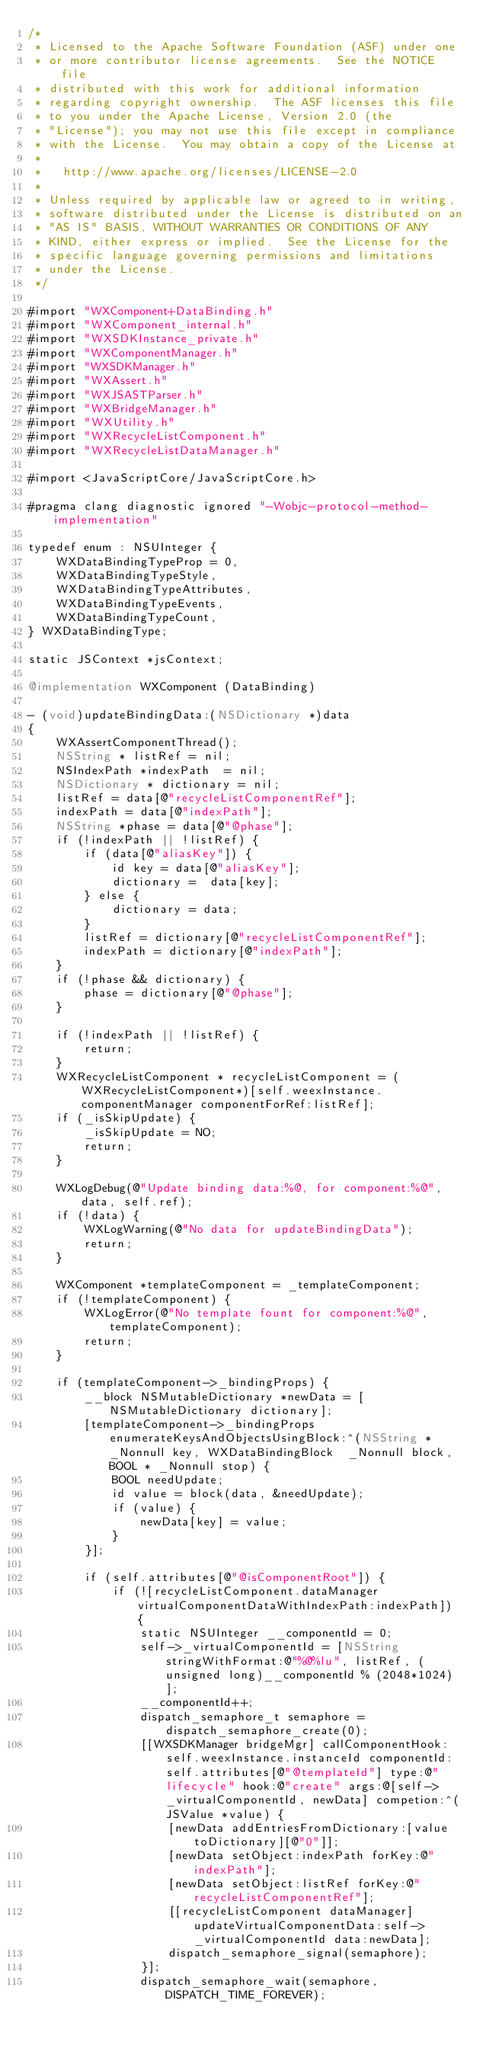<code> <loc_0><loc_0><loc_500><loc_500><_ObjectiveC_>/*
 * Licensed to the Apache Software Foundation (ASF) under one
 * or more contributor license agreements.  See the NOTICE file
 * distributed with this work for additional information
 * regarding copyright ownership.  The ASF licenses this file
 * to you under the Apache License, Version 2.0 (the
 * "License"); you may not use this file except in compliance
 * with the License.  You may obtain a copy of the License at
 *
 *   http://www.apache.org/licenses/LICENSE-2.0
 *
 * Unless required by applicable law or agreed to in writing,
 * software distributed under the License is distributed on an
 * "AS IS" BASIS, WITHOUT WARRANTIES OR CONDITIONS OF ANY
 * KIND, either express or implied.  See the License for the
 * specific language governing permissions and limitations
 * under the License.
 */

#import "WXComponent+DataBinding.h"
#import "WXComponent_internal.h"
#import "WXSDKInstance_private.h"
#import "WXComponentManager.h"
#import "WXSDKManager.h"
#import "WXAssert.h"
#import "WXJSASTParser.h"
#import "WXBridgeManager.h"
#import "WXUtility.h"
#import "WXRecycleListComponent.h"
#import "WXRecycleListDataManager.h"

#import <JavaScriptCore/JavaScriptCore.h>

#pragma clang diagnostic ignored "-Wobjc-protocol-method-implementation"

typedef enum : NSUInteger {
    WXDataBindingTypeProp = 0,
    WXDataBindingTypeStyle,
    WXDataBindingTypeAttributes,
    WXDataBindingTypeEvents,
    WXDataBindingTypeCount,
} WXDataBindingType;

static JSContext *jsContext;

@implementation WXComponent (DataBinding)

- (void)updateBindingData:(NSDictionary *)data
{
    WXAssertComponentThread();
    NSString * listRef = nil;
    NSIndexPath *indexPath  = nil;
    NSDictionary * dictionary = nil;
    listRef = data[@"recycleListComponentRef"];
    indexPath = data[@"indexPath"];
    NSString *phase = data[@"@phase"];
    if (!indexPath || !listRef) {
        if (data[@"aliasKey"]) {
            id key = data[@"aliasKey"];
            dictionary =  data[key];
        } else {
            dictionary = data;
        }
        listRef = dictionary[@"recycleListComponentRef"];
        indexPath = dictionary[@"indexPath"];
    }
    if (!phase && dictionary) {
        phase = dictionary[@"@phase"];
    }
    
    if (!indexPath || !listRef) {
        return;
    }
    WXRecycleListComponent * recycleListComponent = (WXRecycleListComponent*)[self.weexInstance.componentManager componentForRef:listRef];
    if (_isSkipUpdate) {
        _isSkipUpdate = NO;
        return;
    }
    
    WXLogDebug(@"Update binding data:%@, for component:%@", data, self.ref);
    if (!data) {
        WXLogWarning(@"No data for updateBindingData");
        return;
    }
    
    WXComponent *templateComponent = _templateComponent;
    if (!templateComponent) {
        WXLogError(@"No template fount for component:%@", templateComponent);
        return;
    }
    
    if (templateComponent->_bindingProps) {
        __block NSMutableDictionary *newData = [NSMutableDictionary dictionary];
        [templateComponent->_bindingProps enumerateKeysAndObjectsUsingBlock:^(NSString * _Nonnull key, WXDataBindingBlock  _Nonnull block, BOOL * _Nonnull stop) {
            BOOL needUpdate;
            id value = block(data, &needUpdate);
            if (value) {
                newData[key] = value;
            }
        }];
        
        if (self.attributes[@"@isComponentRoot"]) {
            if (![recycleListComponent.dataManager virtualComponentDataWithIndexPath:indexPath]) {
                static NSUInteger __componentId = 0;
                self->_virtualComponentId = [NSString stringWithFormat:@"%@%lu", listRef, (unsigned long)__componentId % (2048*1024)];
                __componentId++;
                dispatch_semaphore_t semaphore = dispatch_semaphore_create(0);
                [[WXSDKManager bridgeMgr] callComponentHook:self.weexInstance.instanceId componentId:self.attributes[@"@templateId"] type:@"lifecycle" hook:@"create" args:@[self->_virtualComponentId, newData] competion:^(JSValue *value) {
                    [newData addEntriesFromDictionary:[value toDictionary][@"0"]];
                    [newData setObject:indexPath forKey:@"indexPath"];
                    [newData setObject:listRef forKey:@"recycleListComponentRef"];
                    [[recycleListComponent dataManager] updateVirtualComponentData:self->_virtualComponentId data:newData];
                    dispatch_semaphore_signal(semaphore);
                }];
                dispatch_semaphore_wait(semaphore, DISPATCH_TIME_FOREVER);
                </code> 